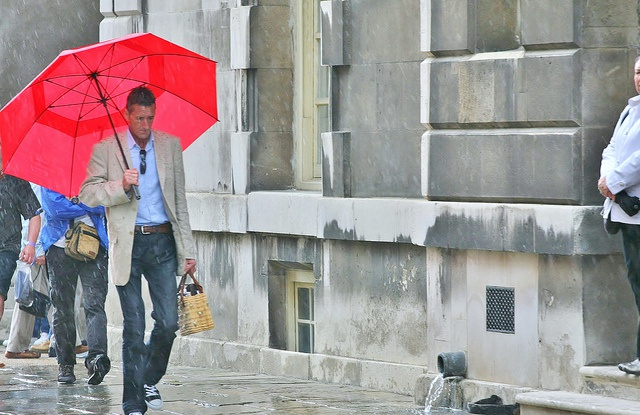Describe the objects in this image and their specific colors. I can see umbrella in darkgray, salmon, red, and brown tones, people in darkgray, blue, gray, and black tones, people in darkgray, gray, purple, black, and lightblue tones, people in darkgray, lavender, and black tones, and people in darkgray, gray, blue, lightpink, and darkblue tones in this image. 